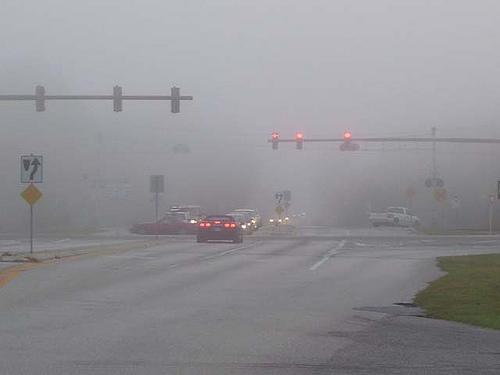What color is the light?
Be succinct. Red. Is it a clear day?
Short answer required. No. What are the cars driving on?
Write a very short answer. Road. Which vehicle is in motion for certain?
Be succinct. Truck. Are there any vehicles in the picture?
Short answer required. Yes. How many lanes can turn left?
Answer briefly. 1. Is it raining or snowing?
Short answer required. Raining. 